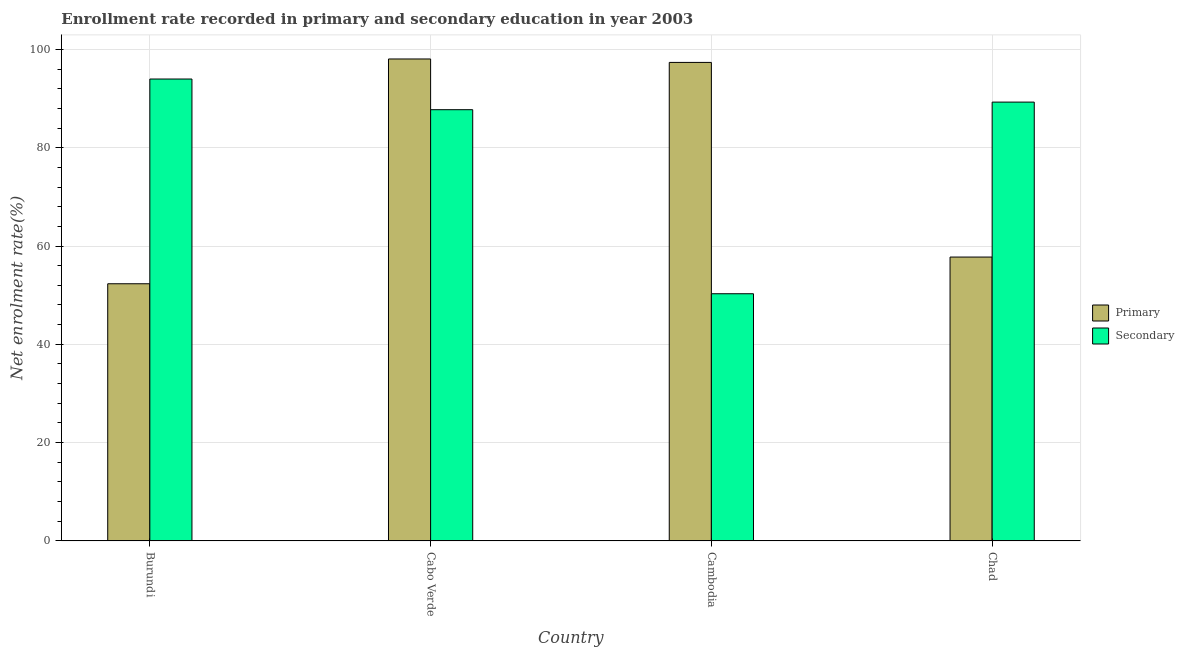How many different coloured bars are there?
Keep it short and to the point. 2. Are the number of bars per tick equal to the number of legend labels?
Make the answer very short. Yes. Are the number of bars on each tick of the X-axis equal?
Your answer should be very brief. Yes. What is the label of the 4th group of bars from the left?
Give a very brief answer. Chad. What is the enrollment rate in secondary education in Chad?
Ensure brevity in your answer.  89.28. Across all countries, what is the maximum enrollment rate in primary education?
Provide a short and direct response. 98.05. Across all countries, what is the minimum enrollment rate in secondary education?
Ensure brevity in your answer.  50.29. In which country was the enrollment rate in secondary education maximum?
Provide a succinct answer. Burundi. In which country was the enrollment rate in secondary education minimum?
Ensure brevity in your answer.  Cambodia. What is the total enrollment rate in secondary education in the graph?
Your answer should be compact. 321.28. What is the difference between the enrollment rate in secondary education in Cabo Verde and that in Chad?
Make the answer very short. -1.55. What is the difference between the enrollment rate in secondary education in Chad and the enrollment rate in primary education in Burundi?
Your response must be concise. 36.96. What is the average enrollment rate in secondary education per country?
Your answer should be compact. 80.32. What is the difference between the enrollment rate in primary education and enrollment rate in secondary education in Cabo Verde?
Your response must be concise. 10.32. What is the ratio of the enrollment rate in primary education in Burundi to that in Cambodia?
Give a very brief answer. 0.54. Is the difference between the enrollment rate in secondary education in Burundi and Chad greater than the difference between the enrollment rate in primary education in Burundi and Chad?
Keep it short and to the point. Yes. What is the difference between the highest and the second highest enrollment rate in primary education?
Provide a succinct answer. 0.7. What is the difference between the highest and the lowest enrollment rate in secondary education?
Keep it short and to the point. 43.68. In how many countries, is the enrollment rate in primary education greater than the average enrollment rate in primary education taken over all countries?
Provide a short and direct response. 2. What does the 2nd bar from the left in Chad represents?
Ensure brevity in your answer.  Secondary. What does the 2nd bar from the right in Burundi represents?
Give a very brief answer. Primary. Are all the bars in the graph horizontal?
Offer a very short reply. No. How many countries are there in the graph?
Keep it short and to the point. 4. What is the difference between two consecutive major ticks on the Y-axis?
Give a very brief answer. 20. Are the values on the major ticks of Y-axis written in scientific E-notation?
Your answer should be very brief. No. Does the graph contain grids?
Your answer should be compact. Yes. Where does the legend appear in the graph?
Keep it short and to the point. Center right. How are the legend labels stacked?
Make the answer very short. Vertical. What is the title of the graph?
Provide a short and direct response. Enrollment rate recorded in primary and secondary education in year 2003. What is the label or title of the Y-axis?
Ensure brevity in your answer.  Net enrolment rate(%). What is the Net enrolment rate(%) of Primary in Burundi?
Ensure brevity in your answer.  52.32. What is the Net enrolment rate(%) of Secondary in Burundi?
Ensure brevity in your answer.  93.98. What is the Net enrolment rate(%) in Primary in Cabo Verde?
Give a very brief answer. 98.05. What is the Net enrolment rate(%) in Secondary in Cabo Verde?
Offer a terse response. 87.73. What is the Net enrolment rate(%) of Primary in Cambodia?
Your response must be concise. 97.35. What is the Net enrolment rate(%) in Secondary in Cambodia?
Give a very brief answer. 50.29. What is the Net enrolment rate(%) of Primary in Chad?
Offer a very short reply. 57.76. What is the Net enrolment rate(%) in Secondary in Chad?
Provide a succinct answer. 89.28. Across all countries, what is the maximum Net enrolment rate(%) of Primary?
Provide a succinct answer. 98.05. Across all countries, what is the maximum Net enrolment rate(%) in Secondary?
Offer a very short reply. 93.98. Across all countries, what is the minimum Net enrolment rate(%) of Primary?
Your response must be concise. 52.32. Across all countries, what is the minimum Net enrolment rate(%) in Secondary?
Your response must be concise. 50.29. What is the total Net enrolment rate(%) of Primary in the graph?
Make the answer very short. 305.48. What is the total Net enrolment rate(%) of Secondary in the graph?
Provide a succinct answer. 321.28. What is the difference between the Net enrolment rate(%) of Primary in Burundi and that in Cabo Verde?
Your answer should be very brief. -45.73. What is the difference between the Net enrolment rate(%) of Secondary in Burundi and that in Cabo Verde?
Your response must be concise. 6.24. What is the difference between the Net enrolment rate(%) in Primary in Burundi and that in Cambodia?
Provide a succinct answer. -45.03. What is the difference between the Net enrolment rate(%) of Secondary in Burundi and that in Cambodia?
Your response must be concise. 43.68. What is the difference between the Net enrolment rate(%) in Primary in Burundi and that in Chad?
Keep it short and to the point. -5.43. What is the difference between the Net enrolment rate(%) of Secondary in Burundi and that in Chad?
Ensure brevity in your answer.  4.69. What is the difference between the Net enrolment rate(%) in Primary in Cabo Verde and that in Cambodia?
Your answer should be compact. 0.7. What is the difference between the Net enrolment rate(%) of Secondary in Cabo Verde and that in Cambodia?
Your answer should be very brief. 37.44. What is the difference between the Net enrolment rate(%) of Primary in Cabo Verde and that in Chad?
Give a very brief answer. 40.3. What is the difference between the Net enrolment rate(%) in Secondary in Cabo Verde and that in Chad?
Give a very brief answer. -1.55. What is the difference between the Net enrolment rate(%) of Primary in Cambodia and that in Chad?
Your response must be concise. 39.6. What is the difference between the Net enrolment rate(%) of Secondary in Cambodia and that in Chad?
Give a very brief answer. -38.99. What is the difference between the Net enrolment rate(%) in Primary in Burundi and the Net enrolment rate(%) in Secondary in Cabo Verde?
Offer a very short reply. -35.41. What is the difference between the Net enrolment rate(%) of Primary in Burundi and the Net enrolment rate(%) of Secondary in Cambodia?
Keep it short and to the point. 2.03. What is the difference between the Net enrolment rate(%) in Primary in Burundi and the Net enrolment rate(%) in Secondary in Chad?
Make the answer very short. -36.96. What is the difference between the Net enrolment rate(%) in Primary in Cabo Verde and the Net enrolment rate(%) in Secondary in Cambodia?
Ensure brevity in your answer.  47.76. What is the difference between the Net enrolment rate(%) in Primary in Cabo Verde and the Net enrolment rate(%) in Secondary in Chad?
Ensure brevity in your answer.  8.77. What is the difference between the Net enrolment rate(%) in Primary in Cambodia and the Net enrolment rate(%) in Secondary in Chad?
Give a very brief answer. 8.07. What is the average Net enrolment rate(%) in Primary per country?
Provide a succinct answer. 76.37. What is the average Net enrolment rate(%) in Secondary per country?
Your answer should be compact. 80.32. What is the difference between the Net enrolment rate(%) in Primary and Net enrolment rate(%) in Secondary in Burundi?
Your response must be concise. -41.65. What is the difference between the Net enrolment rate(%) of Primary and Net enrolment rate(%) of Secondary in Cabo Verde?
Your answer should be very brief. 10.32. What is the difference between the Net enrolment rate(%) in Primary and Net enrolment rate(%) in Secondary in Cambodia?
Your answer should be very brief. 47.06. What is the difference between the Net enrolment rate(%) in Primary and Net enrolment rate(%) in Secondary in Chad?
Keep it short and to the point. -31.53. What is the ratio of the Net enrolment rate(%) of Primary in Burundi to that in Cabo Verde?
Offer a terse response. 0.53. What is the ratio of the Net enrolment rate(%) of Secondary in Burundi to that in Cabo Verde?
Offer a terse response. 1.07. What is the ratio of the Net enrolment rate(%) of Primary in Burundi to that in Cambodia?
Give a very brief answer. 0.54. What is the ratio of the Net enrolment rate(%) of Secondary in Burundi to that in Cambodia?
Provide a succinct answer. 1.87. What is the ratio of the Net enrolment rate(%) of Primary in Burundi to that in Chad?
Make the answer very short. 0.91. What is the ratio of the Net enrolment rate(%) of Secondary in Burundi to that in Chad?
Your answer should be compact. 1.05. What is the ratio of the Net enrolment rate(%) in Primary in Cabo Verde to that in Cambodia?
Your answer should be very brief. 1.01. What is the ratio of the Net enrolment rate(%) of Secondary in Cabo Verde to that in Cambodia?
Ensure brevity in your answer.  1.74. What is the ratio of the Net enrolment rate(%) of Primary in Cabo Verde to that in Chad?
Keep it short and to the point. 1.7. What is the ratio of the Net enrolment rate(%) of Secondary in Cabo Verde to that in Chad?
Make the answer very short. 0.98. What is the ratio of the Net enrolment rate(%) of Primary in Cambodia to that in Chad?
Give a very brief answer. 1.69. What is the ratio of the Net enrolment rate(%) in Secondary in Cambodia to that in Chad?
Ensure brevity in your answer.  0.56. What is the difference between the highest and the second highest Net enrolment rate(%) of Primary?
Your response must be concise. 0.7. What is the difference between the highest and the second highest Net enrolment rate(%) of Secondary?
Offer a terse response. 4.69. What is the difference between the highest and the lowest Net enrolment rate(%) in Primary?
Keep it short and to the point. 45.73. What is the difference between the highest and the lowest Net enrolment rate(%) of Secondary?
Ensure brevity in your answer.  43.68. 